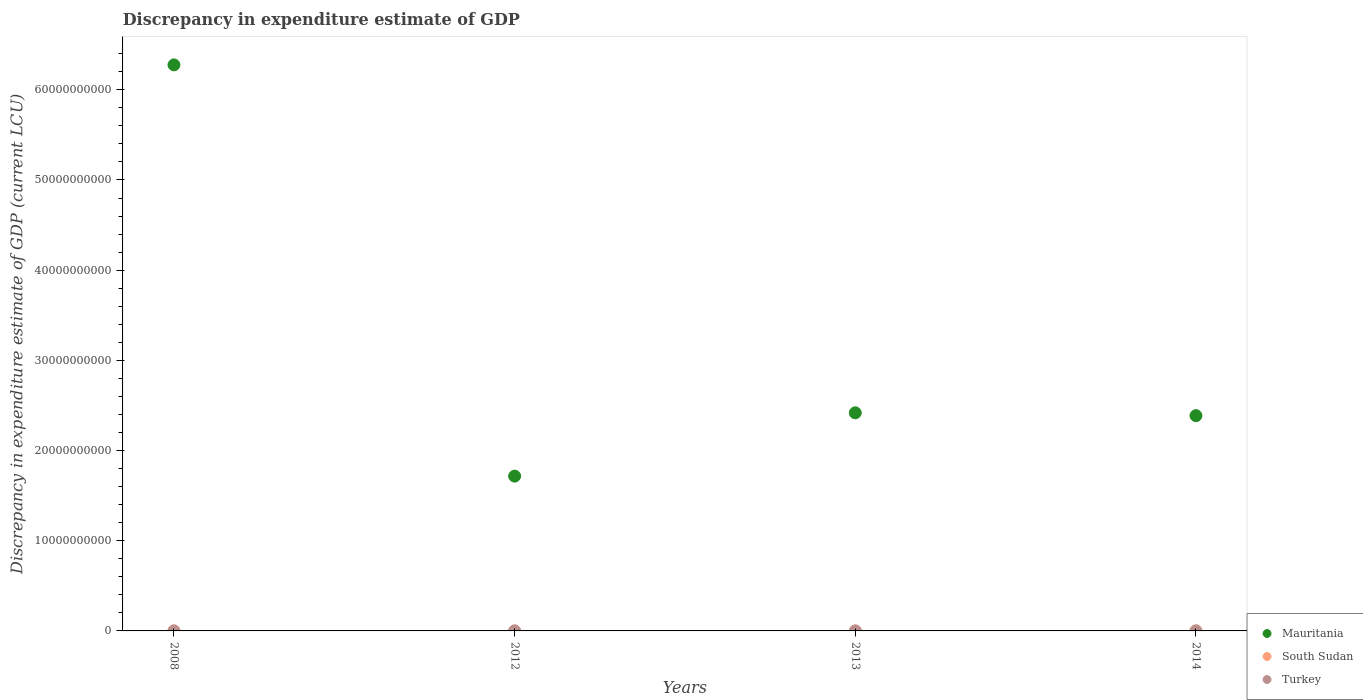How many different coloured dotlines are there?
Give a very brief answer. 3. What is the discrepancy in expenditure estimate of GDP in South Sudan in 2014?
Ensure brevity in your answer.  0. Across all years, what is the maximum discrepancy in expenditure estimate of GDP in South Sudan?
Provide a short and direct response. 2.53e+04. Across all years, what is the minimum discrepancy in expenditure estimate of GDP in South Sudan?
Your answer should be compact. 0. What is the total discrepancy in expenditure estimate of GDP in Mauritania in the graph?
Your answer should be compact. 1.28e+11. What is the difference between the discrepancy in expenditure estimate of GDP in Turkey in 2012 and that in 2013?
Keep it short and to the point. 100. What is the difference between the discrepancy in expenditure estimate of GDP in South Sudan in 2008 and the discrepancy in expenditure estimate of GDP in Turkey in 2012?
Provide a succinct answer. -100. What is the average discrepancy in expenditure estimate of GDP in Turkey per year?
Make the answer very short. 25. In the year 2014, what is the difference between the discrepancy in expenditure estimate of GDP in South Sudan and discrepancy in expenditure estimate of GDP in Mauritania?
Keep it short and to the point. -2.39e+1. What is the ratio of the discrepancy in expenditure estimate of GDP in Turkey in 2008 to that in 2012?
Your answer should be compact. 7e-7. What is the difference between the highest and the second highest discrepancy in expenditure estimate of GDP in Turkey?
Offer a terse response. 100. What is the difference between the highest and the lowest discrepancy in expenditure estimate of GDP in South Sudan?
Make the answer very short. 2.53e+04. In how many years, is the discrepancy in expenditure estimate of GDP in South Sudan greater than the average discrepancy in expenditure estimate of GDP in South Sudan taken over all years?
Provide a succinct answer. 1. Is it the case that in every year, the sum of the discrepancy in expenditure estimate of GDP in Turkey and discrepancy in expenditure estimate of GDP in South Sudan  is greater than the discrepancy in expenditure estimate of GDP in Mauritania?
Your response must be concise. No. Is the discrepancy in expenditure estimate of GDP in Mauritania strictly less than the discrepancy in expenditure estimate of GDP in Turkey over the years?
Ensure brevity in your answer.  No. How many dotlines are there?
Your response must be concise. 3. How many years are there in the graph?
Provide a succinct answer. 4. What is the difference between two consecutive major ticks on the Y-axis?
Ensure brevity in your answer.  1.00e+1. Are the values on the major ticks of Y-axis written in scientific E-notation?
Provide a short and direct response. No. Does the graph contain any zero values?
Your answer should be very brief. Yes. Where does the legend appear in the graph?
Make the answer very short. Bottom right. What is the title of the graph?
Provide a succinct answer. Discrepancy in expenditure estimate of GDP. What is the label or title of the Y-axis?
Give a very brief answer. Discrepancy in expenditure estimate of GDP (current LCU). What is the Discrepancy in expenditure estimate of GDP (current LCU) of Mauritania in 2008?
Your answer should be very brief. 6.28e+1. What is the Discrepancy in expenditure estimate of GDP (current LCU) of South Sudan in 2008?
Provide a succinct answer. 0. What is the Discrepancy in expenditure estimate of GDP (current LCU) of Turkey in 2008?
Keep it short and to the point. 7e-5. What is the Discrepancy in expenditure estimate of GDP (current LCU) in Mauritania in 2012?
Your answer should be compact. 1.72e+1. What is the Discrepancy in expenditure estimate of GDP (current LCU) in South Sudan in 2012?
Your answer should be compact. 0. What is the Discrepancy in expenditure estimate of GDP (current LCU) in Mauritania in 2013?
Your answer should be compact. 2.42e+1. What is the Discrepancy in expenditure estimate of GDP (current LCU) in South Sudan in 2013?
Offer a terse response. 2.53e+04. What is the Discrepancy in expenditure estimate of GDP (current LCU) of Turkey in 2013?
Provide a short and direct response. 0. What is the Discrepancy in expenditure estimate of GDP (current LCU) in Mauritania in 2014?
Offer a very short reply. 2.39e+1. What is the Discrepancy in expenditure estimate of GDP (current LCU) of South Sudan in 2014?
Your answer should be compact. 0. Across all years, what is the maximum Discrepancy in expenditure estimate of GDP (current LCU) of Mauritania?
Provide a short and direct response. 6.28e+1. Across all years, what is the maximum Discrepancy in expenditure estimate of GDP (current LCU) in South Sudan?
Provide a succinct answer. 2.53e+04. Across all years, what is the minimum Discrepancy in expenditure estimate of GDP (current LCU) of Mauritania?
Your answer should be compact. 1.72e+1. Across all years, what is the minimum Discrepancy in expenditure estimate of GDP (current LCU) in South Sudan?
Ensure brevity in your answer.  0. Across all years, what is the minimum Discrepancy in expenditure estimate of GDP (current LCU) in Turkey?
Make the answer very short. 0. What is the total Discrepancy in expenditure estimate of GDP (current LCU) of Mauritania in the graph?
Offer a terse response. 1.28e+11. What is the total Discrepancy in expenditure estimate of GDP (current LCU) in South Sudan in the graph?
Provide a succinct answer. 2.53e+04. What is the total Discrepancy in expenditure estimate of GDP (current LCU) of Turkey in the graph?
Your answer should be compact. 100. What is the difference between the Discrepancy in expenditure estimate of GDP (current LCU) in Mauritania in 2008 and that in 2012?
Ensure brevity in your answer.  4.56e+1. What is the difference between the Discrepancy in expenditure estimate of GDP (current LCU) in Turkey in 2008 and that in 2012?
Provide a short and direct response. -100. What is the difference between the Discrepancy in expenditure estimate of GDP (current LCU) of Mauritania in 2008 and that in 2013?
Keep it short and to the point. 3.86e+1. What is the difference between the Discrepancy in expenditure estimate of GDP (current LCU) of Turkey in 2008 and that in 2013?
Offer a very short reply. -0. What is the difference between the Discrepancy in expenditure estimate of GDP (current LCU) in Mauritania in 2008 and that in 2014?
Make the answer very short. 3.89e+1. What is the difference between the Discrepancy in expenditure estimate of GDP (current LCU) of Mauritania in 2012 and that in 2013?
Offer a terse response. -7.02e+09. What is the difference between the Discrepancy in expenditure estimate of GDP (current LCU) of Turkey in 2012 and that in 2013?
Make the answer very short. 100. What is the difference between the Discrepancy in expenditure estimate of GDP (current LCU) in Mauritania in 2012 and that in 2014?
Offer a terse response. -6.70e+09. What is the difference between the Discrepancy in expenditure estimate of GDP (current LCU) in Mauritania in 2013 and that in 2014?
Your answer should be very brief. 3.15e+08. What is the difference between the Discrepancy in expenditure estimate of GDP (current LCU) in South Sudan in 2013 and that in 2014?
Keep it short and to the point. 2.53e+04. What is the difference between the Discrepancy in expenditure estimate of GDP (current LCU) in Mauritania in 2008 and the Discrepancy in expenditure estimate of GDP (current LCU) in Turkey in 2012?
Offer a very short reply. 6.28e+1. What is the difference between the Discrepancy in expenditure estimate of GDP (current LCU) in Mauritania in 2008 and the Discrepancy in expenditure estimate of GDP (current LCU) in South Sudan in 2013?
Your answer should be compact. 6.28e+1. What is the difference between the Discrepancy in expenditure estimate of GDP (current LCU) in Mauritania in 2008 and the Discrepancy in expenditure estimate of GDP (current LCU) in Turkey in 2013?
Give a very brief answer. 6.28e+1. What is the difference between the Discrepancy in expenditure estimate of GDP (current LCU) of Mauritania in 2008 and the Discrepancy in expenditure estimate of GDP (current LCU) of South Sudan in 2014?
Your answer should be compact. 6.28e+1. What is the difference between the Discrepancy in expenditure estimate of GDP (current LCU) of Mauritania in 2012 and the Discrepancy in expenditure estimate of GDP (current LCU) of South Sudan in 2013?
Provide a succinct answer. 1.72e+1. What is the difference between the Discrepancy in expenditure estimate of GDP (current LCU) in Mauritania in 2012 and the Discrepancy in expenditure estimate of GDP (current LCU) in Turkey in 2013?
Offer a very short reply. 1.72e+1. What is the difference between the Discrepancy in expenditure estimate of GDP (current LCU) of Mauritania in 2012 and the Discrepancy in expenditure estimate of GDP (current LCU) of South Sudan in 2014?
Make the answer very short. 1.72e+1. What is the difference between the Discrepancy in expenditure estimate of GDP (current LCU) in Mauritania in 2013 and the Discrepancy in expenditure estimate of GDP (current LCU) in South Sudan in 2014?
Offer a terse response. 2.42e+1. What is the average Discrepancy in expenditure estimate of GDP (current LCU) in Mauritania per year?
Provide a short and direct response. 3.20e+1. What is the average Discrepancy in expenditure estimate of GDP (current LCU) of South Sudan per year?
Your response must be concise. 6323.6. What is the average Discrepancy in expenditure estimate of GDP (current LCU) of Turkey per year?
Provide a short and direct response. 25. In the year 2008, what is the difference between the Discrepancy in expenditure estimate of GDP (current LCU) of Mauritania and Discrepancy in expenditure estimate of GDP (current LCU) of Turkey?
Keep it short and to the point. 6.28e+1. In the year 2012, what is the difference between the Discrepancy in expenditure estimate of GDP (current LCU) of Mauritania and Discrepancy in expenditure estimate of GDP (current LCU) of Turkey?
Your response must be concise. 1.72e+1. In the year 2013, what is the difference between the Discrepancy in expenditure estimate of GDP (current LCU) in Mauritania and Discrepancy in expenditure estimate of GDP (current LCU) in South Sudan?
Keep it short and to the point. 2.42e+1. In the year 2013, what is the difference between the Discrepancy in expenditure estimate of GDP (current LCU) of Mauritania and Discrepancy in expenditure estimate of GDP (current LCU) of Turkey?
Your answer should be very brief. 2.42e+1. In the year 2013, what is the difference between the Discrepancy in expenditure estimate of GDP (current LCU) in South Sudan and Discrepancy in expenditure estimate of GDP (current LCU) in Turkey?
Offer a very short reply. 2.53e+04. In the year 2014, what is the difference between the Discrepancy in expenditure estimate of GDP (current LCU) in Mauritania and Discrepancy in expenditure estimate of GDP (current LCU) in South Sudan?
Your answer should be compact. 2.39e+1. What is the ratio of the Discrepancy in expenditure estimate of GDP (current LCU) in Mauritania in 2008 to that in 2012?
Give a very brief answer. 3.66. What is the ratio of the Discrepancy in expenditure estimate of GDP (current LCU) of Mauritania in 2008 to that in 2013?
Give a very brief answer. 2.6. What is the ratio of the Discrepancy in expenditure estimate of GDP (current LCU) in Turkey in 2008 to that in 2013?
Your answer should be very brief. 0.27. What is the ratio of the Discrepancy in expenditure estimate of GDP (current LCU) of Mauritania in 2008 to that in 2014?
Provide a succinct answer. 2.63. What is the ratio of the Discrepancy in expenditure estimate of GDP (current LCU) in Mauritania in 2012 to that in 2013?
Give a very brief answer. 0.71. What is the ratio of the Discrepancy in expenditure estimate of GDP (current LCU) in Turkey in 2012 to that in 2013?
Your answer should be very brief. 3.85e+05. What is the ratio of the Discrepancy in expenditure estimate of GDP (current LCU) in Mauritania in 2012 to that in 2014?
Make the answer very short. 0.72. What is the ratio of the Discrepancy in expenditure estimate of GDP (current LCU) in Mauritania in 2013 to that in 2014?
Ensure brevity in your answer.  1.01. What is the ratio of the Discrepancy in expenditure estimate of GDP (current LCU) of South Sudan in 2013 to that in 2014?
Give a very brief answer. 2.31e+08. What is the difference between the highest and the second highest Discrepancy in expenditure estimate of GDP (current LCU) in Mauritania?
Your answer should be very brief. 3.86e+1. What is the difference between the highest and the second highest Discrepancy in expenditure estimate of GDP (current LCU) of Turkey?
Your answer should be compact. 100. What is the difference between the highest and the lowest Discrepancy in expenditure estimate of GDP (current LCU) of Mauritania?
Provide a short and direct response. 4.56e+1. What is the difference between the highest and the lowest Discrepancy in expenditure estimate of GDP (current LCU) of South Sudan?
Offer a very short reply. 2.53e+04. 